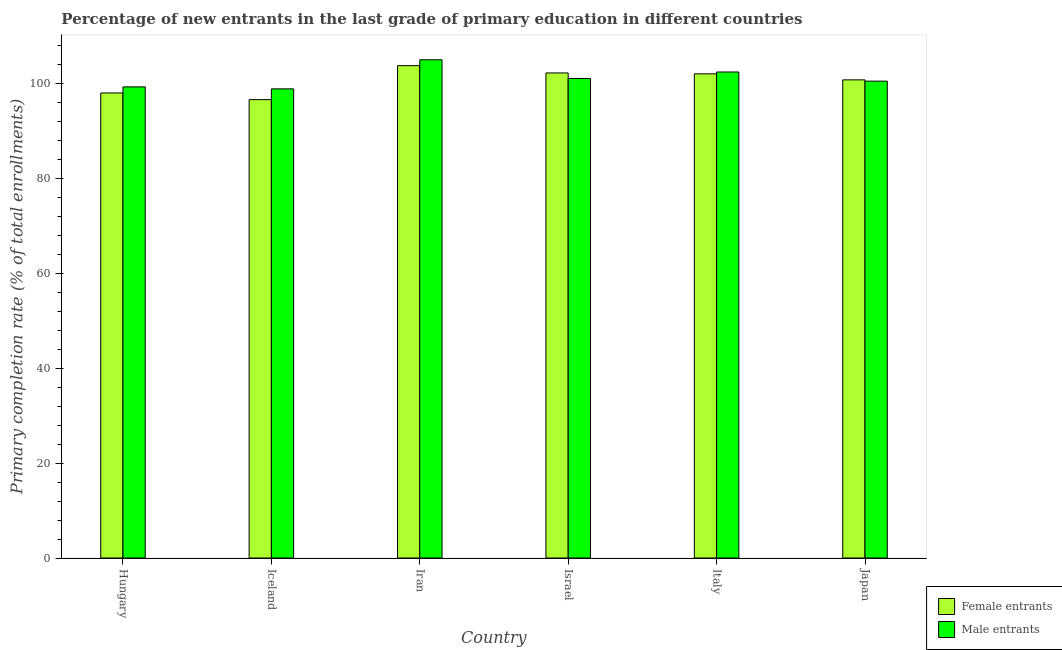How many different coloured bars are there?
Your answer should be compact. 2. How many groups of bars are there?
Make the answer very short. 6. Are the number of bars per tick equal to the number of legend labels?
Ensure brevity in your answer.  Yes. How many bars are there on the 4th tick from the right?
Your answer should be compact. 2. What is the label of the 1st group of bars from the left?
Provide a succinct answer. Hungary. What is the primary completion rate of male entrants in Iran?
Provide a succinct answer. 104.97. Across all countries, what is the maximum primary completion rate of male entrants?
Offer a terse response. 104.97. Across all countries, what is the minimum primary completion rate of male entrants?
Offer a very short reply. 98.84. In which country was the primary completion rate of female entrants maximum?
Provide a short and direct response. Iran. In which country was the primary completion rate of female entrants minimum?
Provide a short and direct response. Iceland. What is the total primary completion rate of male entrants in the graph?
Make the answer very short. 606.97. What is the difference between the primary completion rate of female entrants in Hungary and that in Iran?
Make the answer very short. -5.76. What is the difference between the primary completion rate of male entrants in Iran and the primary completion rate of female entrants in Hungary?
Keep it short and to the point. 6.99. What is the average primary completion rate of male entrants per country?
Make the answer very short. 101.16. What is the difference between the primary completion rate of male entrants and primary completion rate of female entrants in Japan?
Keep it short and to the point. -0.27. In how many countries, is the primary completion rate of male entrants greater than 64 %?
Ensure brevity in your answer.  6. What is the ratio of the primary completion rate of female entrants in Israel to that in Japan?
Offer a very short reply. 1.01. What is the difference between the highest and the second highest primary completion rate of male entrants?
Ensure brevity in your answer.  2.57. What is the difference between the highest and the lowest primary completion rate of male entrants?
Your response must be concise. 6.13. In how many countries, is the primary completion rate of female entrants greater than the average primary completion rate of female entrants taken over all countries?
Offer a very short reply. 4. Is the sum of the primary completion rate of female entrants in Israel and Italy greater than the maximum primary completion rate of male entrants across all countries?
Provide a short and direct response. Yes. What does the 2nd bar from the left in Iran represents?
Ensure brevity in your answer.  Male entrants. What does the 1st bar from the right in Iran represents?
Ensure brevity in your answer.  Male entrants. Are all the bars in the graph horizontal?
Provide a short and direct response. No. What is the difference between two consecutive major ticks on the Y-axis?
Keep it short and to the point. 20. Are the values on the major ticks of Y-axis written in scientific E-notation?
Give a very brief answer. No. Does the graph contain grids?
Ensure brevity in your answer.  No. Where does the legend appear in the graph?
Ensure brevity in your answer.  Bottom right. How many legend labels are there?
Your answer should be compact. 2. How are the legend labels stacked?
Provide a short and direct response. Vertical. What is the title of the graph?
Your answer should be compact. Percentage of new entrants in the last grade of primary education in different countries. Does "% of GNI" appear as one of the legend labels in the graph?
Make the answer very short. No. What is the label or title of the X-axis?
Keep it short and to the point. Country. What is the label or title of the Y-axis?
Your answer should be very brief. Primary completion rate (% of total enrollments). What is the Primary completion rate (% of total enrollments) in Female entrants in Hungary?
Your response must be concise. 97.98. What is the Primary completion rate (% of total enrollments) of Male entrants in Hungary?
Your response must be concise. 99.26. What is the Primary completion rate (% of total enrollments) in Female entrants in Iceland?
Provide a succinct answer. 96.57. What is the Primary completion rate (% of total enrollments) in Male entrants in Iceland?
Make the answer very short. 98.84. What is the Primary completion rate (% of total enrollments) of Female entrants in Iran?
Your answer should be very brief. 103.74. What is the Primary completion rate (% of total enrollments) of Male entrants in Iran?
Make the answer very short. 104.97. What is the Primary completion rate (% of total enrollments) of Female entrants in Israel?
Provide a succinct answer. 102.19. What is the Primary completion rate (% of total enrollments) in Male entrants in Israel?
Provide a succinct answer. 101.03. What is the Primary completion rate (% of total enrollments) of Female entrants in Italy?
Provide a short and direct response. 102.01. What is the Primary completion rate (% of total enrollments) in Male entrants in Italy?
Offer a terse response. 102.4. What is the Primary completion rate (% of total enrollments) in Female entrants in Japan?
Offer a very short reply. 100.74. What is the Primary completion rate (% of total enrollments) in Male entrants in Japan?
Your answer should be very brief. 100.47. Across all countries, what is the maximum Primary completion rate (% of total enrollments) in Female entrants?
Ensure brevity in your answer.  103.74. Across all countries, what is the maximum Primary completion rate (% of total enrollments) in Male entrants?
Provide a succinct answer. 104.97. Across all countries, what is the minimum Primary completion rate (% of total enrollments) in Female entrants?
Provide a short and direct response. 96.57. Across all countries, what is the minimum Primary completion rate (% of total enrollments) of Male entrants?
Keep it short and to the point. 98.84. What is the total Primary completion rate (% of total enrollments) of Female entrants in the graph?
Offer a terse response. 603.23. What is the total Primary completion rate (% of total enrollments) in Male entrants in the graph?
Provide a short and direct response. 606.97. What is the difference between the Primary completion rate (% of total enrollments) of Female entrants in Hungary and that in Iceland?
Your answer should be compact. 1.4. What is the difference between the Primary completion rate (% of total enrollments) in Male entrants in Hungary and that in Iceland?
Ensure brevity in your answer.  0.42. What is the difference between the Primary completion rate (% of total enrollments) in Female entrants in Hungary and that in Iran?
Your answer should be compact. -5.76. What is the difference between the Primary completion rate (% of total enrollments) in Male entrants in Hungary and that in Iran?
Offer a terse response. -5.71. What is the difference between the Primary completion rate (% of total enrollments) in Female entrants in Hungary and that in Israel?
Give a very brief answer. -4.22. What is the difference between the Primary completion rate (% of total enrollments) in Male entrants in Hungary and that in Israel?
Offer a terse response. -1.77. What is the difference between the Primary completion rate (% of total enrollments) in Female entrants in Hungary and that in Italy?
Give a very brief answer. -4.03. What is the difference between the Primary completion rate (% of total enrollments) of Male entrants in Hungary and that in Italy?
Keep it short and to the point. -3.14. What is the difference between the Primary completion rate (% of total enrollments) of Female entrants in Hungary and that in Japan?
Your response must be concise. -2.76. What is the difference between the Primary completion rate (% of total enrollments) in Male entrants in Hungary and that in Japan?
Offer a terse response. -1.21. What is the difference between the Primary completion rate (% of total enrollments) of Female entrants in Iceland and that in Iran?
Your answer should be very brief. -7.16. What is the difference between the Primary completion rate (% of total enrollments) in Male entrants in Iceland and that in Iran?
Your answer should be very brief. -6.13. What is the difference between the Primary completion rate (% of total enrollments) in Female entrants in Iceland and that in Israel?
Ensure brevity in your answer.  -5.62. What is the difference between the Primary completion rate (% of total enrollments) in Male entrants in Iceland and that in Israel?
Offer a very short reply. -2.19. What is the difference between the Primary completion rate (% of total enrollments) of Female entrants in Iceland and that in Italy?
Ensure brevity in your answer.  -5.43. What is the difference between the Primary completion rate (% of total enrollments) in Male entrants in Iceland and that in Italy?
Offer a terse response. -3.55. What is the difference between the Primary completion rate (% of total enrollments) in Female entrants in Iceland and that in Japan?
Ensure brevity in your answer.  -4.17. What is the difference between the Primary completion rate (% of total enrollments) of Male entrants in Iceland and that in Japan?
Ensure brevity in your answer.  -1.62. What is the difference between the Primary completion rate (% of total enrollments) in Female entrants in Iran and that in Israel?
Keep it short and to the point. 1.54. What is the difference between the Primary completion rate (% of total enrollments) in Male entrants in Iran and that in Israel?
Offer a very short reply. 3.94. What is the difference between the Primary completion rate (% of total enrollments) in Female entrants in Iran and that in Italy?
Offer a terse response. 1.73. What is the difference between the Primary completion rate (% of total enrollments) of Male entrants in Iran and that in Italy?
Make the answer very short. 2.57. What is the difference between the Primary completion rate (% of total enrollments) in Female entrants in Iran and that in Japan?
Your answer should be very brief. 3. What is the difference between the Primary completion rate (% of total enrollments) in Male entrants in Iran and that in Japan?
Your answer should be very brief. 4.5. What is the difference between the Primary completion rate (% of total enrollments) in Female entrants in Israel and that in Italy?
Ensure brevity in your answer.  0.19. What is the difference between the Primary completion rate (% of total enrollments) of Male entrants in Israel and that in Italy?
Ensure brevity in your answer.  -1.37. What is the difference between the Primary completion rate (% of total enrollments) in Female entrants in Israel and that in Japan?
Provide a short and direct response. 1.45. What is the difference between the Primary completion rate (% of total enrollments) of Male entrants in Israel and that in Japan?
Provide a succinct answer. 0.56. What is the difference between the Primary completion rate (% of total enrollments) of Female entrants in Italy and that in Japan?
Provide a succinct answer. 1.27. What is the difference between the Primary completion rate (% of total enrollments) in Male entrants in Italy and that in Japan?
Your answer should be very brief. 1.93. What is the difference between the Primary completion rate (% of total enrollments) in Female entrants in Hungary and the Primary completion rate (% of total enrollments) in Male entrants in Iceland?
Your answer should be very brief. -0.87. What is the difference between the Primary completion rate (% of total enrollments) in Female entrants in Hungary and the Primary completion rate (% of total enrollments) in Male entrants in Iran?
Provide a succinct answer. -6.99. What is the difference between the Primary completion rate (% of total enrollments) in Female entrants in Hungary and the Primary completion rate (% of total enrollments) in Male entrants in Israel?
Provide a succinct answer. -3.05. What is the difference between the Primary completion rate (% of total enrollments) of Female entrants in Hungary and the Primary completion rate (% of total enrollments) of Male entrants in Italy?
Provide a short and direct response. -4.42. What is the difference between the Primary completion rate (% of total enrollments) of Female entrants in Hungary and the Primary completion rate (% of total enrollments) of Male entrants in Japan?
Offer a very short reply. -2.49. What is the difference between the Primary completion rate (% of total enrollments) in Female entrants in Iceland and the Primary completion rate (% of total enrollments) in Male entrants in Iran?
Offer a very short reply. -8.39. What is the difference between the Primary completion rate (% of total enrollments) of Female entrants in Iceland and the Primary completion rate (% of total enrollments) of Male entrants in Israel?
Offer a terse response. -4.46. What is the difference between the Primary completion rate (% of total enrollments) in Female entrants in Iceland and the Primary completion rate (% of total enrollments) in Male entrants in Italy?
Give a very brief answer. -5.82. What is the difference between the Primary completion rate (% of total enrollments) in Female entrants in Iceland and the Primary completion rate (% of total enrollments) in Male entrants in Japan?
Provide a succinct answer. -3.89. What is the difference between the Primary completion rate (% of total enrollments) in Female entrants in Iran and the Primary completion rate (% of total enrollments) in Male entrants in Israel?
Your answer should be very brief. 2.71. What is the difference between the Primary completion rate (% of total enrollments) of Female entrants in Iran and the Primary completion rate (% of total enrollments) of Male entrants in Italy?
Make the answer very short. 1.34. What is the difference between the Primary completion rate (% of total enrollments) of Female entrants in Iran and the Primary completion rate (% of total enrollments) of Male entrants in Japan?
Provide a succinct answer. 3.27. What is the difference between the Primary completion rate (% of total enrollments) of Female entrants in Israel and the Primary completion rate (% of total enrollments) of Male entrants in Italy?
Your answer should be very brief. -0.2. What is the difference between the Primary completion rate (% of total enrollments) in Female entrants in Israel and the Primary completion rate (% of total enrollments) in Male entrants in Japan?
Offer a very short reply. 1.73. What is the difference between the Primary completion rate (% of total enrollments) of Female entrants in Italy and the Primary completion rate (% of total enrollments) of Male entrants in Japan?
Provide a succinct answer. 1.54. What is the average Primary completion rate (% of total enrollments) of Female entrants per country?
Your answer should be compact. 100.54. What is the average Primary completion rate (% of total enrollments) in Male entrants per country?
Provide a short and direct response. 101.16. What is the difference between the Primary completion rate (% of total enrollments) of Female entrants and Primary completion rate (% of total enrollments) of Male entrants in Hungary?
Give a very brief answer. -1.28. What is the difference between the Primary completion rate (% of total enrollments) of Female entrants and Primary completion rate (% of total enrollments) of Male entrants in Iceland?
Offer a very short reply. -2.27. What is the difference between the Primary completion rate (% of total enrollments) of Female entrants and Primary completion rate (% of total enrollments) of Male entrants in Iran?
Your answer should be compact. -1.23. What is the difference between the Primary completion rate (% of total enrollments) of Female entrants and Primary completion rate (% of total enrollments) of Male entrants in Israel?
Offer a very short reply. 1.16. What is the difference between the Primary completion rate (% of total enrollments) of Female entrants and Primary completion rate (% of total enrollments) of Male entrants in Italy?
Provide a succinct answer. -0.39. What is the difference between the Primary completion rate (% of total enrollments) of Female entrants and Primary completion rate (% of total enrollments) of Male entrants in Japan?
Offer a terse response. 0.27. What is the ratio of the Primary completion rate (% of total enrollments) in Female entrants in Hungary to that in Iceland?
Provide a short and direct response. 1.01. What is the ratio of the Primary completion rate (% of total enrollments) of Female entrants in Hungary to that in Iran?
Your response must be concise. 0.94. What is the ratio of the Primary completion rate (% of total enrollments) in Male entrants in Hungary to that in Iran?
Offer a terse response. 0.95. What is the ratio of the Primary completion rate (% of total enrollments) in Female entrants in Hungary to that in Israel?
Offer a very short reply. 0.96. What is the ratio of the Primary completion rate (% of total enrollments) in Male entrants in Hungary to that in Israel?
Your answer should be very brief. 0.98. What is the ratio of the Primary completion rate (% of total enrollments) in Female entrants in Hungary to that in Italy?
Your response must be concise. 0.96. What is the ratio of the Primary completion rate (% of total enrollments) of Male entrants in Hungary to that in Italy?
Give a very brief answer. 0.97. What is the ratio of the Primary completion rate (% of total enrollments) in Female entrants in Hungary to that in Japan?
Provide a succinct answer. 0.97. What is the ratio of the Primary completion rate (% of total enrollments) in Female entrants in Iceland to that in Iran?
Offer a terse response. 0.93. What is the ratio of the Primary completion rate (% of total enrollments) of Male entrants in Iceland to that in Iran?
Offer a terse response. 0.94. What is the ratio of the Primary completion rate (% of total enrollments) in Female entrants in Iceland to that in Israel?
Ensure brevity in your answer.  0.94. What is the ratio of the Primary completion rate (% of total enrollments) in Male entrants in Iceland to that in Israel?
Offer a very short reply. 0.98. What is the ratio of the Primary completion rate (% of total enrollments) of Female entrants in Iceland to that in Italy?
Your answer should be very brief. 0.95. What is the ratio of the Primary completion rate (% of total enrollments) of Male entrants in Iceland to that in Italy?
Provide a succinct answer. 0.97. What is the ratio of the Primary completion rate (% of total enrollments) of Female entrants in Iceland to that in Japan?
Your response must be concise. 0.96. What is the ratio of the Primary completion rate (% of total enrollments) in Male entrants in Iceland to that in Japan?
Provide a short and direct response. 0.98. What is the ratio of the Primary completion rate (% of total enrollments) of Female entrants in Iran to that in Israel?
Make the answer very short. 1.02. What is the ratio of the Primary completion rate (% of total enrollments) of Male entrants in Iran to that in Israel?
Make the answer very short. 1.04. What is the ratio of the Primary completion rate (% of total enrollments) in Female entrants in Iran to that in Italy?
Offer a very short reply. 1.02. What is the ratio of the Primary completion rate (% of total enrollments) in Male entrants in Iran to that in Italy?
Ensure brevity in your answer.  1.03. What is the ratio of the Primary completion rate (% of total enrollments) in Female entrants in Iran to that in Japan?
Make the answer very short. 1.03. What is the ratio of the Primary completion rate (% of total enrollments) in Male entrants in Iran to that in Japan?
Offer a terse response. 1.04. What is the ratio of the Primary completion rate (% of total enrollments) in Male entrants in Israel to that in Italy?
Make the answer very short. 0.99. What is the ratio of the Primary completion rate (% of total enrollments) in Female entrants in Israel to that in Japan?
Offer a very short reply. 1.01. What is the ratio of the Primary completion rate (% of total enrollments) in Male entrants in Israel to that in Japan?
Your answer should be very brief. 1.01. What is the ratio of the Primary completion rate (% of total enrollments) of Female entrants in Italy to that in Japan?
Your answer should be compact. 1.01. What is the ratio of the Primary completion rate (% of total enrollments) of Male entrants in Italy to that in Japan?
Give a very brief answer. 1.02. What is the difference between the highest and the second highest Primary completion rate (% of total enrollments) in Female entrants?
Your response must be concise. 1.54. What is the difference between the highest and the second highest Primary completion rate (% of total enrollments) of Male entrants?
Provide a short and direct response. 2.57. What is the difference between the highest and the lowest Primary completion rate (% of total enrollments) of Female entrants?
Your response must be concise. 7.16. What is the difference between the highest and the lowest Primary completion rate (% of total enrollments) in Male entrants?
Keep it short and to the point. 6.13. 